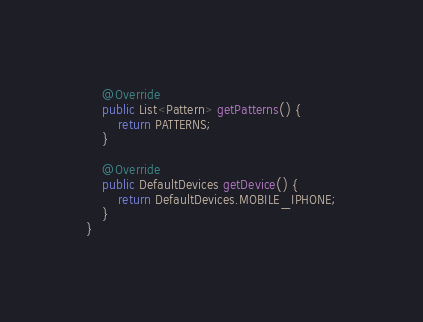Convert code to text. <code><loc_0><loc_0><loc_500><loc_500><_Java_>
    @Override
    public List<Pattern> getPatterns() {
        return PATTERNS;
    }

    @Override
    public DefaultDevices getDevice() {
        return DefaultDevices.MOBILE_IPHONE;
    }
}
</code> 